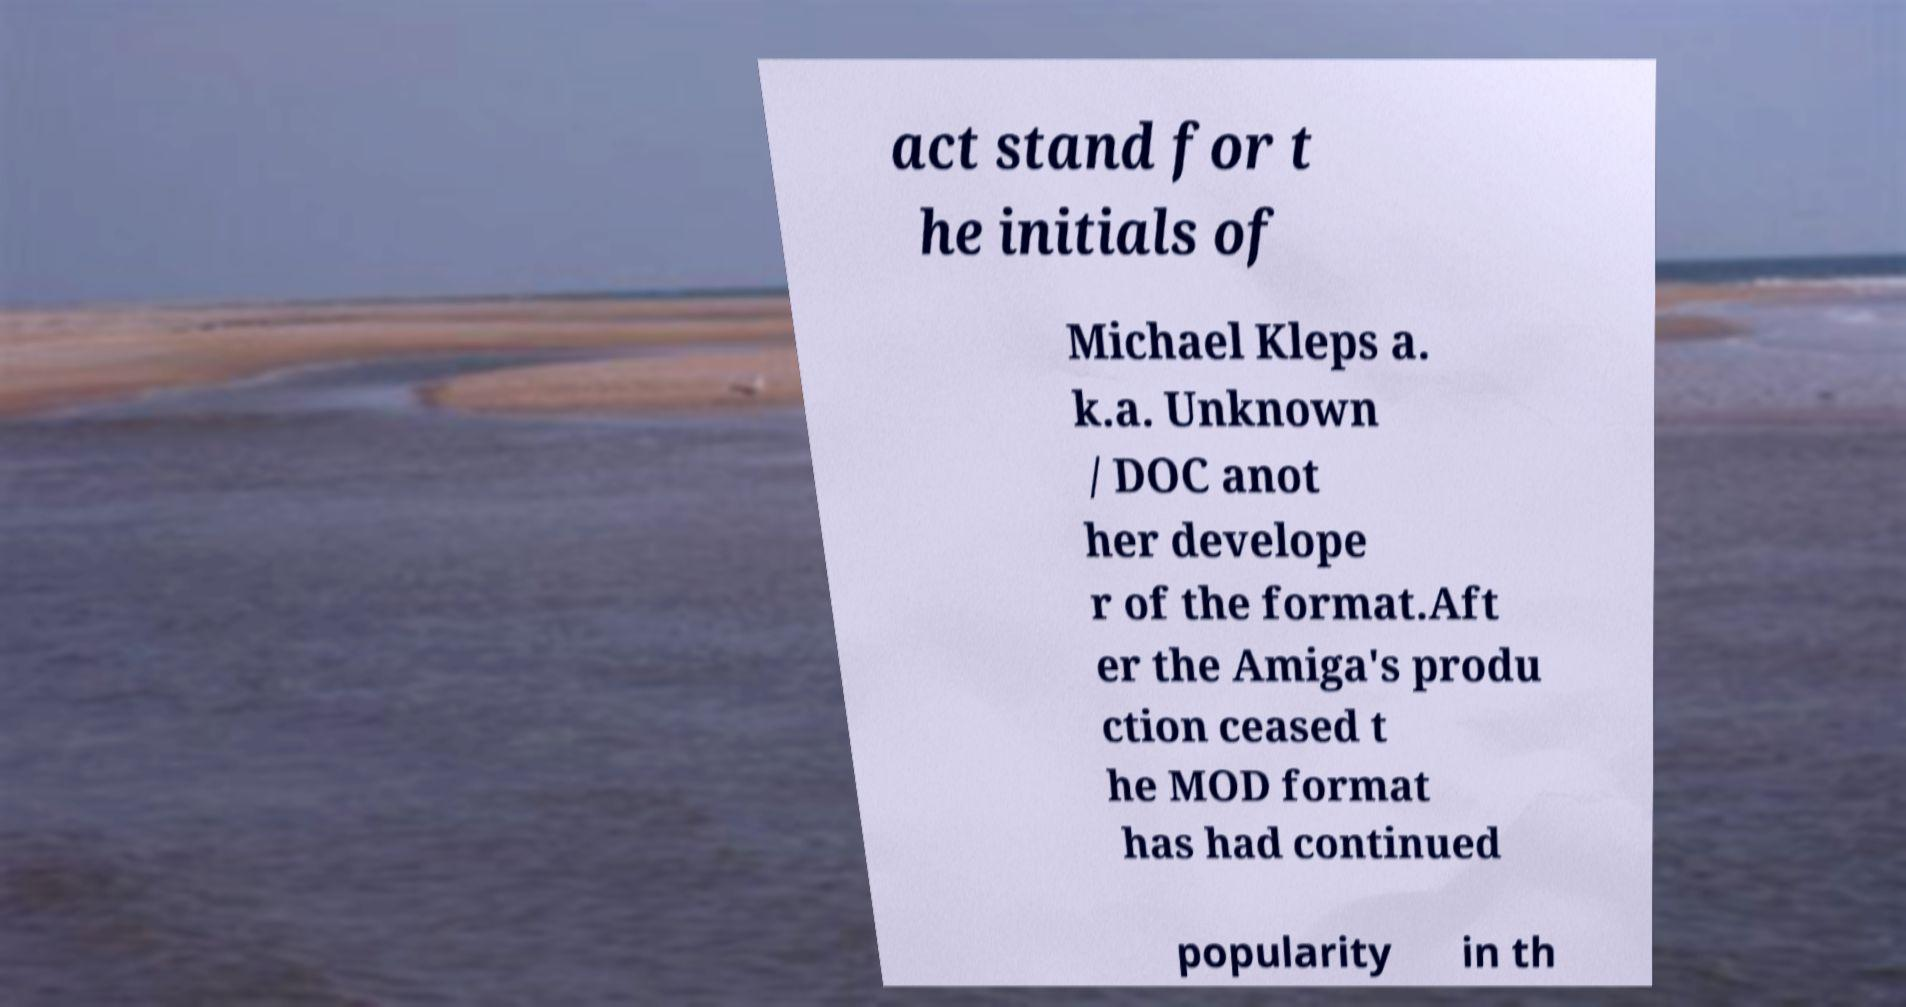Can you read and provide the text displayed in the image?This photo seems to have some interesting text. Can you extract and type it out for me? act stand for t he initials of Michael Kleps a. k.a. Unknown / DOC anot her develope r of the format.Aft er the Amiga's produ ction ceased t he MOD format has had continued popularity in th 